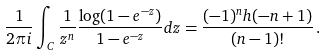Convert formula to latex. <formula><loc_0><loc_0><loc_500><loc_500>\frac { 1 } { 2 \pi i } \int _ { C } \frac { 1 } { z ^ { n } } \frac { \log ( 1 - e ^ { - z } ) } { 1 - e ^ { - z } } d z = \frac { ( - 1 ) ^ { n } h ( - n + 1 ) } { ( n - 1 ) ! } \, .</formula> 